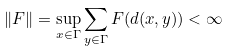<formula> <loc_0><loc_0><loc_500><loc_500>\| F \| = \sup _ { x \in \Gamma } \sum _ { y \in \Gamma } F ( d ( x , y ) ) < \infty</formula> 